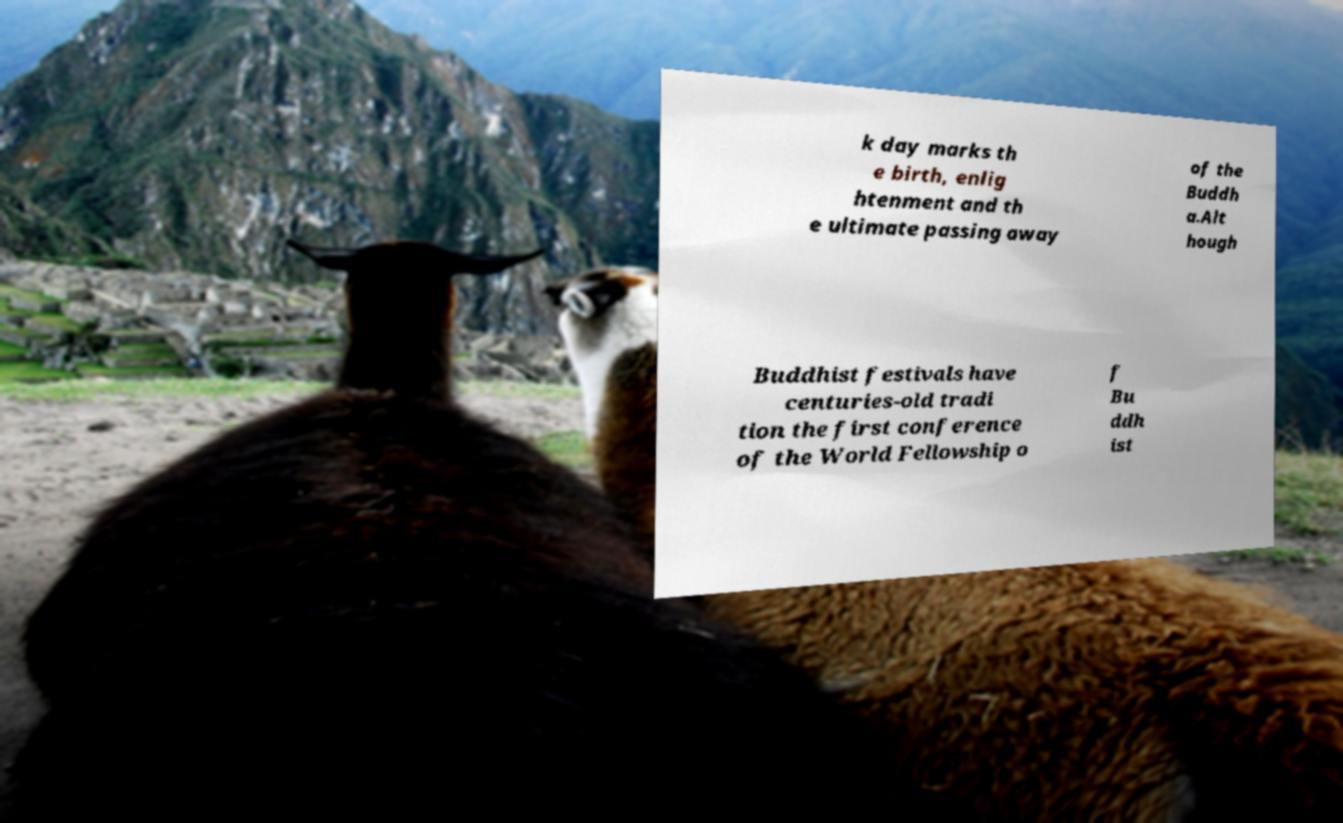Can you accurately transcribe the text from the provided image for me? k day marks th e birth, enlig htenment and th e ultimate passing away of the Buddh a.Alt hough Buddhist festivals have centuries-old tradi tion the first conference of the World Fellowship o f Bu ddh ist 